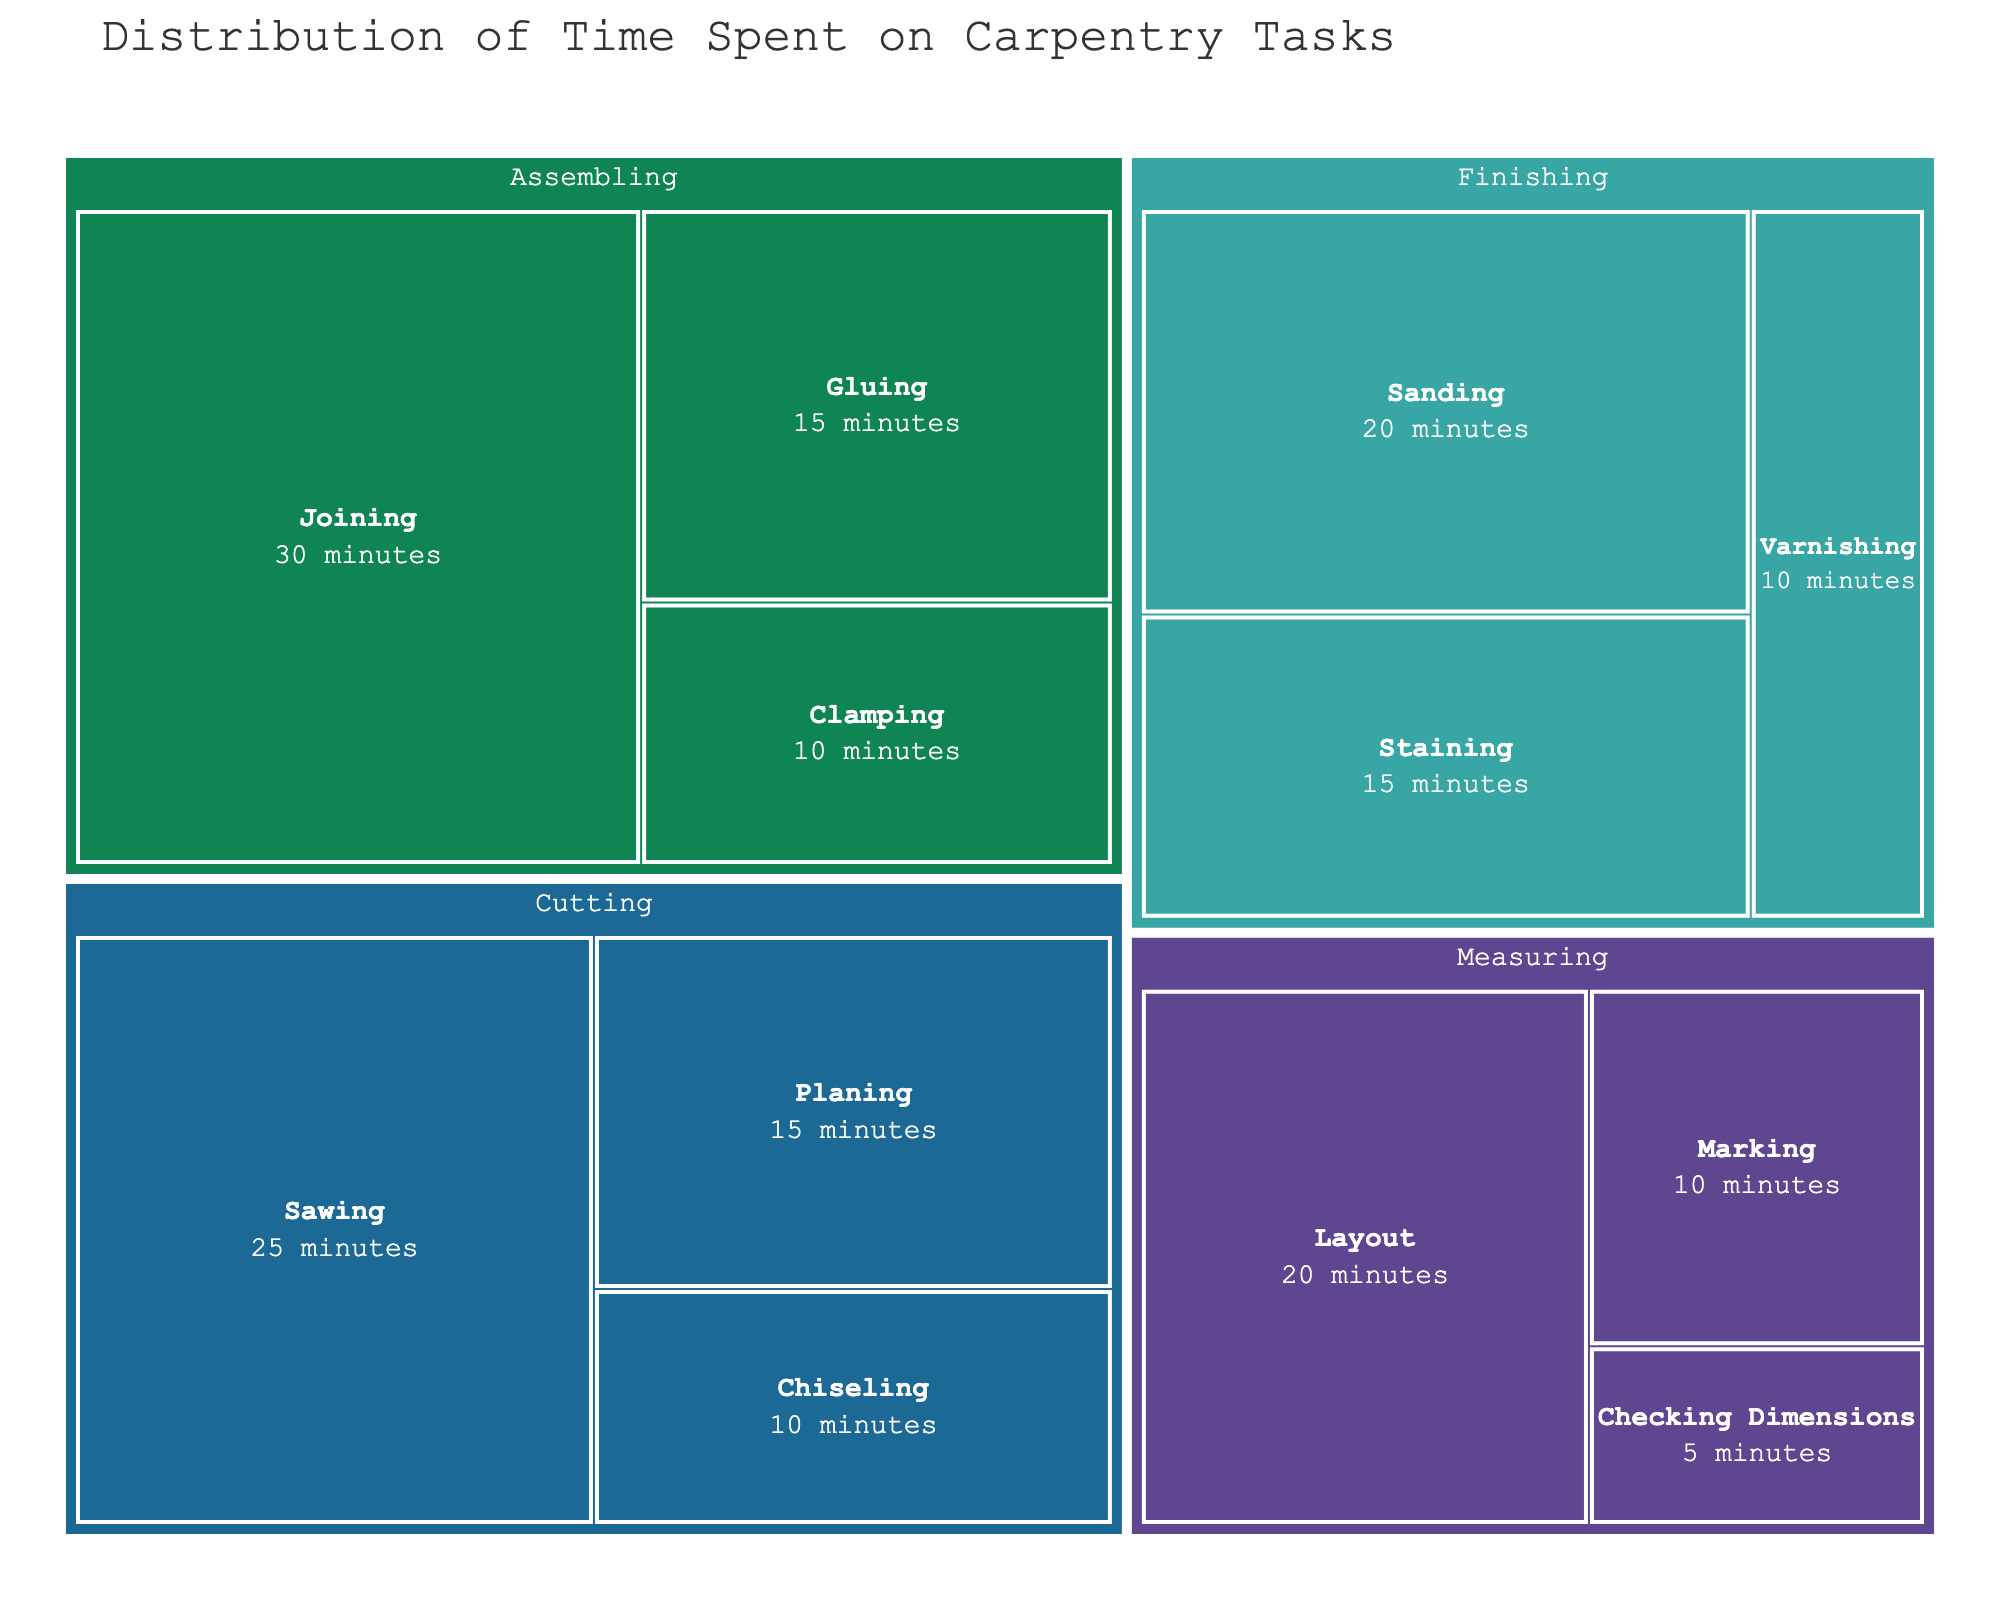what is the task with the most time spent? The task with the largest segment in the treemap is the one with the most time. "Assembling" has the largest segment.
Answer: Assembling Which subtask under "Finishing" takes the most time? Under the "Finishing" category, we compare the sizes of the subtask segments. "Sanding" has the largest segment.
Answer: Sanding what is the total time spent on "Cutting" tasks? Sum of time for Sawing (25), Planing (15), and Chiseling (10) gives 25 + 15 + 10 = 50 minutes.
Answer: 50 minutes Compare the time spent on "Measuring" tasks to "Finishing" tasks. Which is greater? Sum of time for Measuring: Layout (20), Marking (10), Checking Dimensions (5) = 35 minutes. Sum of time for Finishing: Sanding (20), Staining (15), Varnishing (10) = 45 minutes. 45 > 35
Answer: Finishing What proportion of time is spent on "Joining" within the Assembling task? Time for Joining is 30 minutes out of total Assembling time which is Joining (30) + Gluing (15) + Clamping (10) = 55 minutes. Proportion is 30/55 = 0.545 or 54.5%.
Answer: 54.5% How does the time spent on "Sanding" compare to the time spent on "Checking Dimensions"? Sanding takes 20 minutes, while Checking Dimensions takes 5 minutes. 20 > 5.
Answer: Sanding takes more time What is the overall total time spent on all tasks? Total time = Sawing (25) + Planing (15) + Chiseling (10) + Layout (20) + Marking (10) + Checking Dimensions (5) + Joining (30) + Gluing (15) + Clamping (10) + Sanding (20) + Staining (15) + Varnishing (10) = 185 minutes
Answer: 185 minutes If you combine the time spent on "Gluing" and "Planing", how does it compare to time spent on "Layout"? Time for Gluing is 15 minutes, Planing is 15 minutes. Combined, they are 15 + 15 = 30 minutes. Time for Layout is 20 minutes, so 30 > 20.
Answer: Combined time is greater What two subtasks together make up half of the entire "Cutting" task time? Total Cutting time is 50 minutes. Half is 25 minutes. Sawing is 25 minutes. Therefore, "Sawing" itself makes up half. No need for two subtasks.
Answer: Sawing makes up half What is the smallest subtask in terms of time? The smallest segment within the treemap represents the subtask with the least time. "Checking Dimensions" is the smallest with 5 minutes.
Answer: Checking Dimensions 